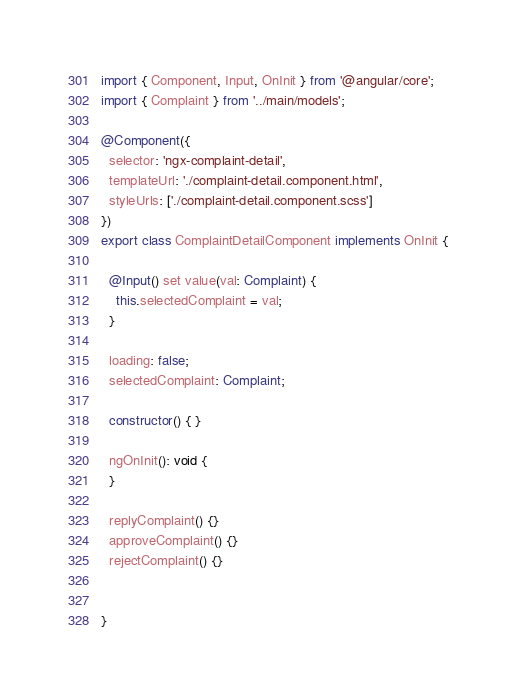<code> <loc_0><loc_0><loc_500><loc_500><_TypeScript_>import { Component, Input, OnInit } from '@angular/core';
import { Complaint } from '../main/models';

@Component({
  selector: 'ngx-complaint-detail',
  templateUrl: './complaint-detail.component.html',
  styleUrls: ['./complaint-detail.component.scss']
})
export class ComplaintDetailComponent implements OnInit {

  @Input() set value(val: Complaint) {
    this.selectedComplaint = val;
  }

  loading: false;
  selectedComplaint: Complaint;

  constructor() { }

  ngOnInit(): void {
  }

  replyComplaint() {}
  approveComplaint() {}
  rejectComplaint() {}


}
</code> 